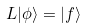<formula> <loc_0><loc_0><loc_500><loc_500>L | \phi \rangle = | f \rangle</formula> 